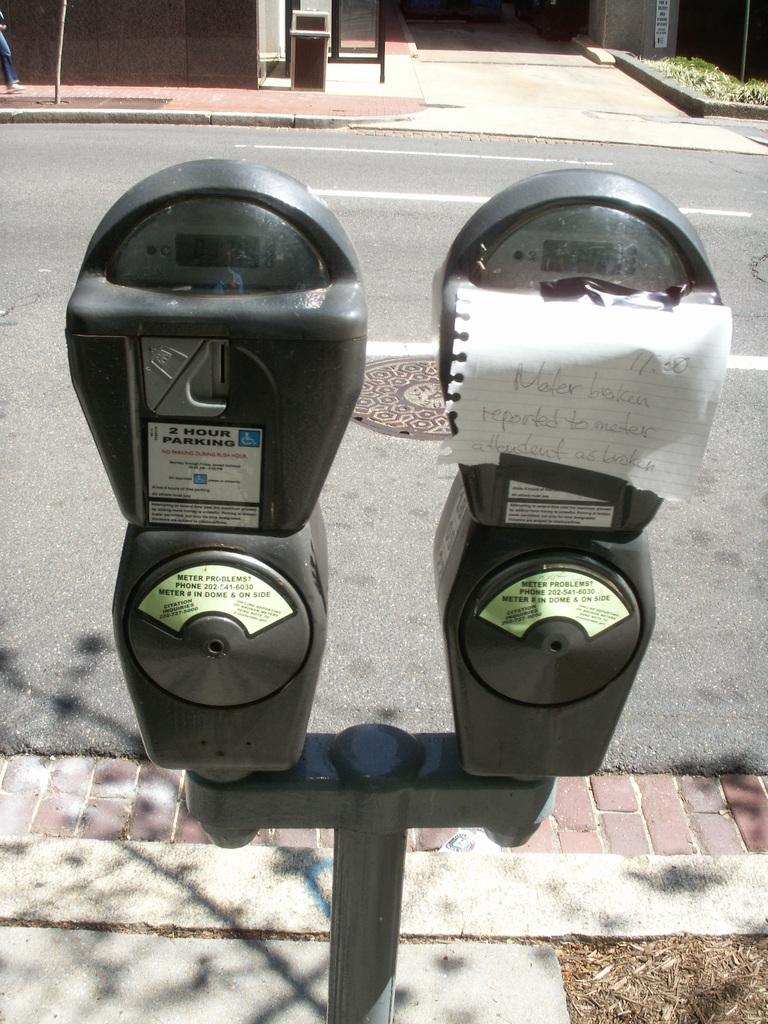<image>
Describe the image concisely. A broken meter, and paper that says Meter broken reported to meter attentant as broken 